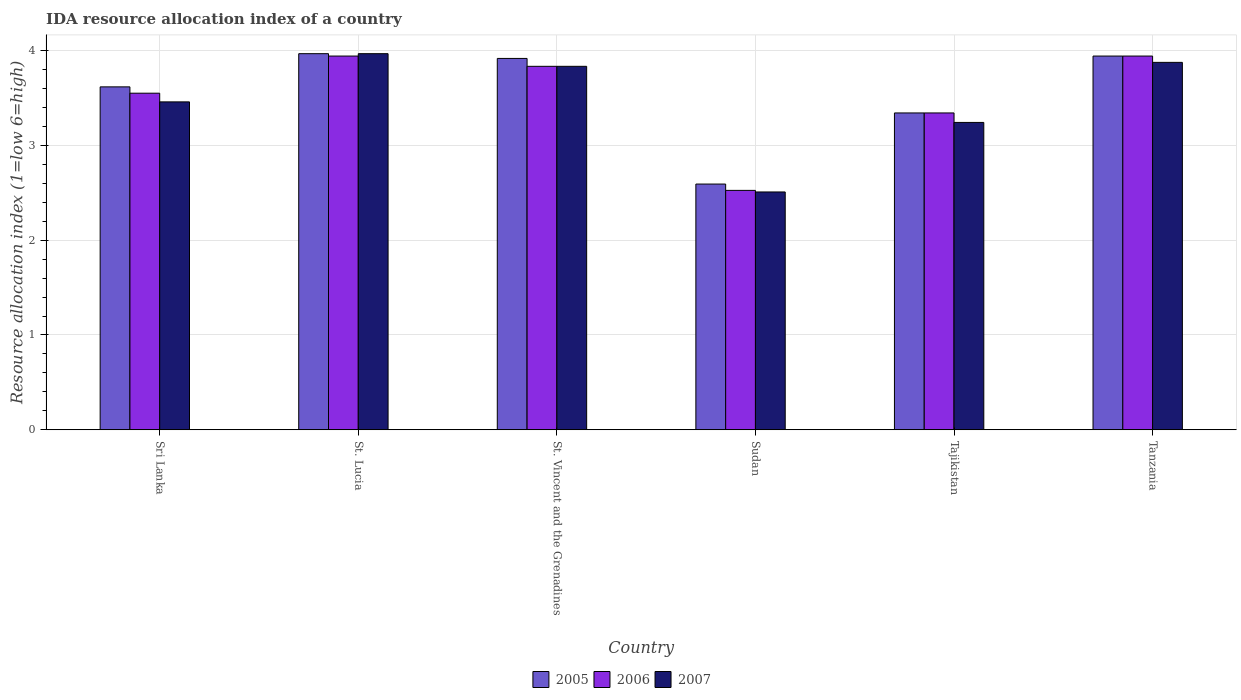How many different coloured bars are there?
Give a very brief answer. 3. How many groups of bars are there?
Your answer should be compact. 6. Are the number of bars on each tick of the X-axis equal?
Provide a succinct answer. Yes. How many bars are there on the 2nd tick from the right?
Provide a succinct answer. 3. What is the label of the 4th group of bars from the left?
Provide a succinct answer. Sudan. What is the IDA resource allocation index in 2006 in St. Vincent and the Grenadines?
Your answer should be compact. 3.83. Across all countries, what is the maximum IDA resource allocation index in 2007?
Give a very brief answer. 3.97. Across all countries, what is the minimum IDA resource allocation index in 2005?
Your answer should be compact. 2.59. In which country was the IDA resource allocation index in 2006 maximum?
Offer a terse response. St. Lucia. In which country was the IDA resource allocation index in 2006 minimum?
Your response must be concise. Sudan. What is the total IDA resource allocation index in 2007 in the graph?
Your answer should be very brief. 20.88. What is the difference between the IDA resource allocation index in 2007 in St. Lucia and that in Tanzania?
Provide a succinct answer. 0.09. What is the difference between the IDA resource allocation index in 2005 in Sri Lanka and the IDA resource allocation index in 2007 in St. Lucia?
Offer a very short reply. -0.35. What is the average IDA resource allocation index in 2005 per country?
Offer a terse response. 3.56. What is the difference between the IDA resource allocation index of/in 2007 and IDA resource allocation index of/in 2006 in St. Lucia?
Offer a very short reply. 0.02. What is the ratio of the IDA resource allocation index in 2007 in St. Lucia to that in Sudan?
Make the answer very short. 1.58. What is the difference between the highest and the second highest IDA resource allocation index in 2005?
Ensure brevity in your answer.  -0.02. What is the difference between the highest and the lowest IDA resource allocation index in 2007?
Your answer should be compact. 1.46. In how many countries, is the IDA resource allocation index in 2005 greater than the average IDA resource allocation index in 2005 taken over all countries?
Offer a terse response. 4. What does the 1st bar from the left in Tanzania represents?
Offer a very short reply. 2005. What does the 1st bar from the right in Tajikistan represents?
Offer a very short reply. 2007. Is it the case that in every country, the sum of the IDA resource allocation index in 2005 and IDA resource allocation index in 2006 is greater than the IDA resource allocation index in 2007?
Ensure brevity in your answer.  Yes. How many bars are there?
Offer a terse response. 18. How many countries are there in the graph?
Provide a succinct answer. 6. What is the difference between two consecutive major ticks on the Y-axis?
Your answer should be compact. 1. Are the values on the major ticks of Y-axis written in scientific E-notation?
Offer a very short reply. No. Does the graph contain any zero values?
Ensure brevity in your answer.  No. Does the graph contain grids?
Ensure brevity in your answer.  Yes. Where does the legend appear in the graph?
Ensure brevity in your answer.  Bottom center. What is the title of the graph?
Make the answer very short. IDA resource allocation index of a country. Does "1977" appear as one of the legend labels in the graph?
Your answer should be compact. No. What is the label or title of the Y-axis?
Keep it short and to the point. Resource allocation index (1=low 6=high). What is the Resource allocation index (1=low 6=high) of 2005 in Sri Lanka?
Your answer should be compact. 3.62. What is the Resource allocation index (1=low 6=high) in 2006 in Sri Lanka?
Provide a short and direct response. 3.55. What is the Resource allocation index (1=low 6=high) in 2007 in Sri Lanka?
Offer a terse response. 3.46. What is the Resource allocation index (1=low 6=high) in 2005 in St. Lucia?
Keep it short and to the point. 3.97. What is the Resource allocation index (1=low 6=high) in 2006 in St. Lucia?
Your answer should be very brief. 3.94. What is the Resource allocation index (1=low 6=high) of 2007 in St. Lucia?
Provide a short and direct response. 3.97. What is the Resource allocation index (1=low 6=high) in 2005 in St. Vincent and the Grenadines?
Keep it short and to the point. 3.92. What is the Resource allocation index (1=low 6=high) of 2006 in St. Vincent and the Grenadines?
Keep it short and to the point. 3.83. What is the Resource allocation index (1=low 6=high) in 2007 in St. Vincent and the Grenadines?
Offer a very short reply. 3.83. What is the Resource allocation index (1=low 6=high) in 2005 in Sudan?
Your answer should be compact. 2.59. What is the Resource allocation index (1=low 6=high) of 2006 in Sudan?
Provide a succinct answer. 2.52. What is the Resource allocation index (1=low 6=high) in 2007 in Sudan?
Ensure brevity in your answer.  2.51. What is the Resource allocation index (1=low 6=high) in 2005 in Tajikistan?
Make the answer very short. 3.34. What is the Resource allocation index (1=low 6=high) in 2006 in Tajikistan?
Your answer should be very brief. 3.34. What is the Resource allocation index (1=low 6=high) of 2007 in Tajikistan?
Provide a succinct answer. 3.24. What is the Resource allocation index (1=low 6=high) of 2005 in Tanzania?
Offer a very short reply. 3.94. What is the Resource allocation index (1=low 6=high) of 2006 in Tanzania?
Give a very brief answer. 3.94. What is the Resource allocation index (1=low 6=high) of 2007 in Tanzania?
Your response must be concise. 3.88. Across all countries, what is the maximum Resource allocation index (1=low 6=high) of 2005?
Provide a succinct answer. 3.97. Across all countries, what is the maximum Resource allocation index (1=low 6=high) of 2006?
Keep it short and to the point. 3.94. Across all countries, what is the maximum Resource allocation index (1=low 6=high) of 2007?
Give a very brief answer. 3.97. Across all countries, what is the minimum Resource allocation index (1=low 6=high) of 2005?
Your response must be concise. 2.59. Across all countries, what is the minimum Resource allocation index (1=low 6=high) of 2006?
Your response must be concise. 2.52. Across all countries, what is the minimum Resource allocation index (1=low 6=high) of 2007?
Your answer should be compact. 2.51. What is the total Resource allocation index (1=low 6=high) in 2005 in the graph?
Offer a terse response. 21.38. What is the total Resource allocation index (1=low 6=high) in 2006 in the graph?
Make the answer very short. 21.13. What is the total Resource allocation index (1=low 6=high) of 2007 in the graph?
Give a very brief answer. 20.88. What is the difference between the Resource allocation index (1=low 6=high) of 2005 in Sri Lanka and that in St. Lucia?
Your response must be concise. -0.35. What is the difference between the Resource allocation index (1=low 6=high) in 2006 in Sri Lanka and that in St. Lucia?
Offer a terse response. -0.39. What is the difference between the Resource allocation index (1=low 6=high) of 2007 in Sri Lanka and that in St. Lucia?
Provide a succinct answer. -0.51. What is the difference between the Resource allocation index (1=low 6=high) of 2006 in Sri Lanka and that in St. Vincent and the Grenadines?
Offer a terse response. -0.28. What is the difference between the Resource allocation index (1=low 6=high) of 2007 in Sri Lanka and that in St. Vincent and the Grenadines?
Your response must be concise. -0.38. What is the difference between the Resource allocation index (1=low 6=high) in 2005 in Sri Lanka and that in Sudan?
Your response must be concise. 1.02. What is the difference between the Resource allocation index (1=low 6=high) in 2006 in Sri Lanka and that in Sudan?
Your answer should be very brief. 1.02. What is the difference between the Resource allocation index (1=low 6=high) in 2007 in Sri Lanka and that in Sudan?
Your answer should be very brief. 0.95. What is the difference between the Resource allocation index (1=low 6=high) of 2005 in Sri Lanka and that in Tajikistan?
Provide a short and direct response. 0.28. What is the difference between the Resource allocation index (1=low 6=high) of 2006 in Sri Lanka and that in Tajikistan?
Make the answer very short. 0.21. What is the difference between the Resource allocation index (1=low 6=high) in 2007 in Sri Lanka and that in Tajikistan?
Give a very brief answer. 0.22. What is the difference between the Resource allocation index (1=low 6=high) of 2005 in Sri Lanka and that in Tanzania?
Your response must be concise. -0.33. What is the difference between the Resource allocation index (1=low 6=high) of 2006 in Sri Lanka and that in Tanzania?
Provide a succinct answer. -0.39. What is the difference between the Resource allocation index (1=low 6=high) of 2007 in Sri Lanka and that in Tanzania?
Provide a succinct answer. -0.42. What is the difference between the Resource allocation index (1=low 6=high) in 2005 in St. Lucia and that in St. Vincent and the Grenadines?
Offer a very short reply. 0.05. What is the difference between the Resource allocation index (1=low 6=high) of 2006 in St. Lucia and that in St. Vincent and the Grenadines?
Make the answer very short. 0.11. What is the difference between the Resource allocation index (1=low 6=high) of 2007 in St. Lucia and that in St. Vincent and the Grenadines?
Keep it short and to the point. 0.13. What is the difference between the Resource allocation index (1=low 6=high) of 2005 in St. Lucia and that in Sudan?
Provide a succinct answer. 1.38. What is the difference between the Resource allocation index (1=low 6=high) in 2006 in St. Lucia and that in Sudan?
Make the answer very short. 1.42. What is the difference between the Resource allocation index (1=low 6=high) in 2007 in St. Lucia and that in Sudan?
Provide a succinct answer. 1.46. What is the difference between the Resource allocation index (1=low 6=high) of 2007 in St. Lucia and that in Tajikistan?
Keep it short and to the point. 0.72. What is the difference between the Resource allocation index (1=low 6=high) in 2005 in St. Lucia and that in Tanzania?
Offer a terse response. 0.03. What is the difference between the Resource allocation index (1=low 6=high) of 2006 in St. Lucia and that in Tanzania?
Your answer should be very brief. 0. What is the difference between the Resource allocation index (1=low 6=high) in 2007 in St. Lucia and that in Tanzania?
Your answer should be very brief. 0.09. What is the difference between the Resource allocation index (1=low 6=high) in 2005 in St. Vincent and the Grenadines and that in Sudan?
Keep it short and to the point. 1.32. What is the difference between the Resource allocation index (1=low 6=high) of 2006 in St. Vincent and the Grenadines and that in Sudan?
Your answer should be compact. 1.31. What is the difference between the Resource allocation index (1=low 6=high) in 2007 in St. Vincent and the Grenadines and that in Sudan?
Your answer should be very brief. 1.32. What is the difference between the Resource allocation index (1=low 6=high) in 2005 in St. Vincent and the Grenadines and that in Tajikistan?
Provide a short and direct response. 0.57. What is the difference between the Resource allocation index (1=low 6=high) in 2006 in St. Vincent and the Grenadines and that in Tajikistan?
Provide a succinct answer. 0.49. What is the difference between the Resource allocation index (1=low 6=high) in 2007 in St. Vincent and the Grenadines and that in Tajikistan?
Provide a succinct answer. 0.59. What is the difference between the Resource allocation index (1=low 6=high) in 2005 in St. Vincent and the Grenadines and that in Tanzania?
Your answer should be compact. -0.03. What is the difference between the Resource allocation index (1=low 6=high) in 2006 in St. Vincent and the Grenadines and that in Tanzania?
Your answer should be very brief. -0.11. What is the difference between the Resource allocation index (1=low 6=high) in 2007 in St. Vincent and the Grenadines and that in Tanzania?
Offer a very short reply. -0.04. What is the difference between the Resource allocation index (1=low 6=high) in 2005 in Sudan and that in Tajikistan?
Give a very brief answer. -0.75. What is the difference between the Resource allocation index (1=low 6=high) of 2006 in Sudan and that in Tajikistan?
Keep it short and to the point. -0.82. What is the difference between the Resource allocation index (1=low 6=high) in 2007 in Sudan and that in Tajikistan?
Give a very brief answer. -0.73. What is the difference between the Resource allocation index (1=low 6=high) of 2005 in Sudan and that in Tanzania?
Keep it short and to the point. -1.35. What is the difference between the Resource allocation index (1=low 6=high) of 2006 in Sudan and that in Tanzania?
Keep it short and to the point. -1.42. What is the difference between the Resource allocation index (1=low 6=high) in 2007 in Sudan and that in Tanzania?
Offer a terse response. -1.37. What is the difference between the Resource allocation index (1=low 6=high) in 2005 in Tajikistan and that in Tanzania?
Your answer should be compact. -0.6. What is the difference between the Resource allocation index (1=low 6=high) of 2007 in Tajikistan and that in Tanzania?
Your answer should be very brief. -0.63. What is the difference between the Resource allocation index (1=low 6=high) of 2005 in Sri Lanka and the Resource allocation index (1=low 6=high) of 2006 in St. Lucia?
Provide a succinct answer. -0.33. What is the difference between the Resource allocation index (1=low 6=high) in 2005 in Sri Lanka and the Resource allocation index (1=low 6=high) in 2007 in St. Lucia?
Give a very brief answer. -0.35. What is the difference between the Resource allocation index (1=low 6=high) in 2006 in Sri Lanka and the Resource allocation index (1=low 6=high) in 2007 in St. Lucia?
Ensure brevity in your answer.  -0.42. What is the difference between the Resource allocation index (1=low 6=high) of 2005 in Sri Lanka and the Resource allocation index (1=low 6=high) of 2006 in St. Vincent and the Grenadines?
Ensure brevity in your answer.  -0.22. What is the difference between the Resource allocation index (1=low 6=high) of 2005 in Sri Lanka and the Resource allocation index (1=low 6=high) of 2007 in St. Vincent and the Grenadines?
Provide a short and direct response. -0.22. What is the difference between the Resource allocation index (1=low 6=high) of 2006 in Sri Lanka and the Resource allocation index (1=low 6=high) of 2007 in St. Vincent and the Grenadines?
Offer a terse response. -0.28. What is the difference between the Resource allocation index (1=low 6=high) in 2005 in Sri Lanka and the Resource allocation index (1=low 6=high) in 2006 in Sudan?
Your response must be concise. 1.09. What is the difference between the Resource allocation index (1=low 6=high) of 2005 in Sri Lanka and the Resource allocation index (1=low 6=high) of 2007 in Sudan?
Your answer should be compact. 1.11. What is the difference between the Resource allocation index (1=low 6=high) of 2006 in Sri Lanka and the Resource allocation index (1=low 6=high) of 2007 in Sudan?
Your answer should be very brief. 1.04. What is the difference between the Resource allocation index (1=low 6=high) in 2005 in Sri Lanka and the Resource allocation index (1=low 6=high) in 2006 in Tajikistan?
Provide a succinct answer. 0.28. What is the difference between the Resource allocation index (1=low 6=high) in 2006 in Sri Lanka and the Resource allocation index (1=low 6=high) in 2007 in Tajikistan?
Provide a short and direct response. 0.31. What is the difference between the Resource allocation index (1=low 6=high) in 2005 in Sri Lanka and the Resource allocation index (1=low 6=high) in 2006 in Tanzania?
Provide a succinct answer. -0.33. What is the difference between the Resource allocation index (1=low 6=high) in 2005 in Sri Lanka and the Resource allocation index (1=low 6=high) in 2007 in Tanzania?
Provide a short and direct response. -0.26. What is the difference between the Resource allocation index (1=low 6=high) of 2006 in Sri Lanka and the Resource allocation index (1=low 6=high) of 2007 in Tanzania?
Keep it short and to the point. -0.33. What is the difference between the Resource allocation index (1=low 6=high) of 2005 in St. Lucia and the Resource allocation index (1=low 6=high) of 2006 in St. Vincent and the Grenadines?
Keep it short and to the point. 0.13. What is the difference between the Resource allocation index (1=low 6=high) of 2005 in St. Lucia and the Resource allocation index (1=low 6=high) of 2007 in St. Vincent and the Grenadines?
Your response must be concise. 0.13. What is the difference between the Resource allocation index (1=low 6=high) of 2006 in St. Lucia and the Resource allocation index (1=low 6=high) of 2007 in St. Vincent and the Grenadines?
Give a very brief answer. 0.11. What is the difference between the Resource allocation index (1=low 6=high) in 2005 in St. Lucia and the Resource allocation index (1=low 6=high) in 2006 in Sudan?
Ensure brevity in your answer.  1.44. What is the difference between the Resource allocation index (1=low 6=high) of 2005 in St. Lucia and the Resource allocation index (1=low 6=high) of 2007 in Sudan?
Your answer should be compact. 1.46. What is the difference between the Resource allocation index (1=low 6=high) in 2006 in St. Lucia and the Resource allocation index (1=low 6=high) in 2007 in Sudan?
Your response must be concise. 1.43. What is the difference between the Resource allocation index (1=low 6=high) of 2005 in St. Lucia and the Resource allocation index (1=low 6=high) of 2007 in Tajikistan?
Keep it short and to the point. 0.72. What is the difference between the Resource allocation index (1=low 6=high) of 2006 in St. Lucia and the Resource allocation index (1=low 6=high) of 2007 in Tajikistan?
Keep it short and to the point. 0.7. What is the difference between the Resource allocation index (1=low 6=high) in 2005 in St. Lucia and the Resource allocation index (1=low 6=high) in 2006 in Tanzania?
Provide a succinct answer. 0.03. What is the difference between the Resource allocation index (1=low 6=high) in 2005 in St. Lucia and the Resource allocation index (1=low 6=high) in 2007 in Tanzania?
Your answer should be compact. 0.09. What is the difference between the Resource allocation index (1=low 6=high) of 2006 in St. Lucia and the Resource allocation index (1=low 6=high) of 2007 in Tanzania?
Give a very brief answer. 0.07. What is the difference between the Resource allocation index (1=low 6=high) in 2005 in St. Vincent and the Grenadines and the Resource allocation index (1=low 6=high) in 2006 in Sudan?
Make the answer very short. 1.39. What is the difference between the Resource allocation index (1=low 6=high) in 2005 in St. Vincent and the Grenadines and the Resource allocation index (1=low 6=high) in 2007 in Sudan?
Provide a succinct answer. 1.41. What is the difference between the Resource allocation index (1=low 6=high) of 2006 in St. Vincent and the Grenadines and the Resource allocation index (1=low 6=high) of 2007 in Sudan?
Offer a terse response. 1.32. What is the difference between the Resource allocation index (1=low 6=high) of 2005 in St. Vincent and the Grenadines and the Resource allocation index (1=low 6=high) of 2006 in Tajikistan?
Your answer should be very brief. 0.57. What is the difference between the Resource allocation index (1=low 6=high) in 2005 in St. Vincent and the Grenadines and the Resource allocation index (1=low 6=high) in 2007 in Tajikistan?
Ensure brevity in your answer.  0.68. What is the difference between the Resource allocation index (1=low 6=high) in 2006 in St. Vincent and the Grenadines and the Resource allocation index (1=low 6=high) in 2007 in Tajikistan?
Your response must be concise. 0.59. What is the difference between the Resource allocation index (1=low 6=high) in 2005 in St. Vincent and the Grenadines and the Resource allocation index (1=low 6=high) in 2006 in Tanzania?
Offer a terse response. -0.03. What is the difference between the Resource allocation index (1=low 6=high) in 2005 in St. Vincent and the Grenadines and the Resource allocation index (1=low 6=high) in 2007 in Tanzania?
Provide a short and direct response. 0.04. What is the difference between the Resource allocation index (1=low 6=high) of 2006 in St. Vincent and the Grenadines and the Resource allocation index (1=low 6=high) of 2007 in Tanzania?
Make the answer very short. -0.04. What is the difference between the Resource allocation index (1=low 6=high) of 2005 in Sudan and the Resource allocation index (1=low 6=high) of 2006 in Tajikistan?
Give a very brief answer. -0.75. What is the difference between the Resource allocation index (1=low 6=high) in 2005 in Sudan and the Resource allocation index (1=low 6=high) in 2007 in Tajikistan?
Give a very brief answer. -0.65. What is the difference between the Resource allocation index (1=low 6=high) of 2006 in Sudan and the Resource allocation index (1=low 6=high) of 2007 in Tajikistan?
Offer a very short reply. -0.72. What is the difference between the Resource allocation index (1=low 6=high) of 2005 in Sudan and the Resource allocation index (1=low 6=high) of 2006 in Tanzania?
Provide a short and direct response. -1.35. What is the difference between the Resource allocation index (1=low 6=high) in 2005 in Sudan and the Resource allocation index (1=low 6=high) in 2007 in Tanzania?
Provide a short and direct response. -1.28. What is the difference between the Resource allocation index (1=low 6=high) of 2006 in Sudan and the Resource allocation index (1=low 6=high) of 2007 in Tanzania?
Your answer should be very brief. -1.35. What is the difference between the Resource allocation index (1=low 6=high) of 2005 in Tajikistan and the Resource allocation index (1=low 6=high) of 2007 in Tanzania?
Your response must be concise. -0.53. What is the difference between the Resource allocation index (1=low 6=high) in 2006 in Tajikistan and the Resource allocation index (1=low 6=high) in 2007 in Tanzania?
Provide a short and direct response. -0.53. What is the average Resource allocation index (1=low 6=high) of 2005 per country?
Keep it short and to the point. 3.56. What is the average Resource allocation index (1=low 6=high) in 2006 per country?
Your response must be concise. 3.52. What is the average Resource allocation index (1=low 6=high) of 2007 per country?
Provide a succinct answer. 3.48. What is the difference between the Resource allocation index (1=low 6=high) of 2005 and Resource allocation index (1=low 6=high) of 2006 in Sri Lanka?
Ensure brevity in your answer.  0.07. What is the difference between the Resource allocation index (1=low 6=high) of 2005 and Resource allocation index (1=low 6=high) of 2007 in Sri Lanka?
Your answer should be very brief. 0.16. What is the difference between the Resource allocation index (1=low 6=high) of 2006 and Resource allocation index (1=low 6=high) of 2007 in Sri Lanka?
Offer a terse response. 0.09. What is the difference between the Resource allocation index (1=low 6=high) of 2005 and Resource allocation index (1=low 6=high) of 2006 in St. Lucia?
Offer a very short reply. 0.03. What is the difference between the Resource allocation index (1=low 6=high) in 2006 and Resource allocation index (1=low 6=high) in 2007 in St. Lucia?
Your response must be concise. -0.03. What is the difference between the Resource allocation index (1=low 6=high) in 2005 and Resource allocation index (1=low 6=high) in 2006 in St. Vincent and the Grenadines?
Give a very brief answer. 0.08. What is the difference between the Resource allocation index (1=low 6=high) of 2005 and Resource allocation index (1=low 6=high) of 2007 in St. Vincent and the Grenadines?
Make the answer very short. 0.08. What is the difference between the Resource allocation index (1=low 6=high) in 2005 and Resource allocation index (1=low 6=high) in 2006 in Sudan?
Give a very brief answer. 0.07. What is the difference between the Resource allocation index (1=low 6=high) in 2005 and Resource allocation index (1=low 6=high) in 2007 in Sudan?
Ensure brevity in your answer.  0.08. What is the difference between the Resource allocation index (1=low 6=high) of 2006 and Resource allocation index (1=low 6=high) of 2007 in Sudan?
Give a very brief answer. 0.02. What is the difference between the Resource allocation index (1=low 6=high) in 2005 and Resource allocation index (1=low 6=high) in 2007 in Tanzania?
Your answer should be compact. 0.07. What is the difference between the Resource allocation index (1=low 6=high) in 2006 and Resource allocation index (1=low 6=high) in 2007 in Tanzania?
Make the answer very short. 0.07. What is the ratio of the Resource allocation index (1=low 6=high) in 2005 in Sri Lanka to that in St. Lucia?
Your answer should be very brief. 0.91. What is the ratio of the Resource allocation index (1=low 6=high) in 2006 in Sri Lanka to that in St. Lucia?
Your answer should be compact. 0.9. What is the ratio of the Resource allocation index (1=low 6=high) of 2007 in Sri Lanka to that in St. Lucia?
Provide a succinct answer. 0.87. What is the ratio of the Resource allocation index (1=low 6=high) in 2005 in Sri Lanka to that in St. Vincent and the Grenadines?
Your answer should be very brief. 0.92. What is the ratio of the Resource allocation index (1=low 6=high) in 2006 in Sri Lanka to that in St. Vincent and the Grenadines?
Ensure brevity in your answer.  0.93. What is the ratio of the Resource allocation index (1=low 6=high) of 2007 in Sri Lanka to that in St. Vincent and the Grenadines?
Offer a very short reply. 0.9. What is the ratio of the Resource allocation index (1=low 6=high) in 2005 in Sri Lanka to that in Sudan?
Offer a very short reply. 1.4. What is the ratio of the Resource allocation index (1=low 6=high) in 2006 in Sri Lanka to that in Sudan?
Your response must be concise. 1.41. What is the ratio of the Resource allocation index (1=low 6=high) of 2007 in Sri Lanka to that in Sudan?
Offer a very short reply. 1.38. What is the ratio of the Resource allocation index (1=low 6=high) of 2005 in Sri Lanka to that in Tajikistan?
Give a very brief answer. 1.08. What is the ratio of the Resource allocation index (1=low 6=high) of 2006 in Sri Lanka to that in Tajikistan?
Your answer should be very brief. 1.06. What is the ratio of the Resource allocation index (1=low 6=high) in 2007 in Sri Lanka to that in Tajikistan?
Keep it short and to the point. 1.07. What is the ratio of the Resource allocation index (1=low 6=high) of 2005 in Sri Lanka to that in Tanzania?
Give a very brief answer. 0.92. What is the ratio of the Resource allocation index (1=low 6=high) of 2006 in Sri Lanka to that in Tanzania?
Ensure brevity in your answer.  0.9. What is the ratio of the Resource allocation index (1=low 6=high) of 2007 in Sri Lanka to that in Tanzania?
Your response must be concise. 0.89. What is the ratio of the Resource allocation index (1=low 6=high) in 2005 in St. Lucia to that in St. Vincent and the Grenadines?
Offer a terse response. 1.01. What is the ratio of the Resource allocation index (1=low 6=high) of 2006 in St. Lucia to that in St. Vincent and the Grenadines?
Offer a very short reply. 1.03. What is the ratio of the Resource allocation index (1=low 6=high) in 2007 in St. Lucia to that in St. Vincent and the Grenadines?
Provide a succinct answer. 1.03. What is the ratio of the Resource allocation index (1=low 6=high) in 2005 in St. Lucia to that in Sudan?
Your answer should be very brief. 1.53. What is the ratio of the Resource allocation index (1=low 6=high) of 2006 in St. Lucia to that in Sudan?
Offer a very short reply. 1.56. What is the ratio of the Resource allocation index (1=low 6=high) of 2007 in St. Lucia to that in Sudan?
Provide a short and direct response. 1.58. What is the ratio of the Resource allocation index (1=low 6=high) of 2005 in St. Lucia to that in Tajikistan?
Your answer should be very brief. 1.19. What is the ratio of the Resource allocation index (1=low 6=high) in 2006 in St. Lucia to that in Tajikistan?
Your response must be concise. 1.18. What is the ratio of the Resource allocation index (1=low 6=high) of 2007 in St. Lucia to that in Tajikistan?
Your answer should be very brief. 1.22. What is the ratio of the Resource allocation index (1=low 6=high) of 2005 in St. Lucia to that in Tanzania?
Your answer should be compact. 1.01. What is the ratio of the Resource allocation index (1=low 6=high) of 2006 in St. Lucia to that in Tanzania?
Keep it short and to the point. 1. What is the ratio of the Resource allocation index (1=low 6=high) in 2007 in St. Lucia to that in Tanzania?
Your answer should be compact. 1.02. What is the ratio of the Resource allocation index (1=low 6=high) of 2005 in St. Vincent and the Grenadines to that in Sudan?
Provide a succinct answer. 1.51. What is the ratio of the Resource allocation index (1=low 6=high) in 2006 in St. Vincent and the Grenadines to that in Sudan?
Your response must be concise. 1.52. What is the ratio of the Resource allocation index (1=low 6=high) of 2007 in St. Vincent and the Grenadines to that in Sudan?
Provide a succinct answer. 1.53. What is the ratio of the Resource allocation index (1=low 6=high) in 2005 in St. Vincent and the Grenadines to that in Tajikistan?
Make the answer very short. 1.17. What is the ratio of the Resource allocation index (1=low 6=high) of 2006 in St. Vincent and the Grenadines to that in Tajikistan?
Give a very brief answer. 1.15. What is the ratio of the Resource allocation index (1=low 6=high) of 2007 in St. Vincent and the Grenadines to that in Tajikistan?
Ensure brevity in your answer.  1.18. What is the ratio of the Resource allocation index (1=low 6=high) in 2005 in St. Vincent and the Grenadines to that in Tanzania?
Your answer should be very brief. 0.99. What is the ratio of the Resource allocation index (1=low 6=high) of 2006 in St. Vincent and the Grenadines to that in Tanzania?
Ensure brevity in your answer.  0.97. What is the ratio of the Resource allocation index (1=low 6=high) of 2007 in St. Vincent and the Grenadines to that in Tanzania?
Your answer should be very brief. 0.99. What is the ratio of the Resource allocation index (1=low 6=high) in 2005 in Sudan to that in Tajikistan?
Provide a short and direct response. 0.78. What is the ratio of the Resource allocation index (1=low 6=high) in 2006 in Sudan to that in Tajikistan?
Offer a very short reply. 0.76. What is the ratio of the Resource allocation index (1=low 6=high) in 2007 in Sudan to that in Tajikistan?
Your response must be concise. 0.77. What is the ratio of the Resource allocation index (1=low 6=high) of 2005 in Sudan to that in Tanzania?
Offer a very short reply. 0.66. What is the ratio of the Resource allocation index (1=low 6=high) in 2006 in Sudan to that in Tanzania?
Offer a very short reply. 0.64. What is the ratio of the Resource allocation index (1=low 6=high) of 2007 in Sudan to that in Tanzania?
Ensure brevity in your answer.  0.65. What is the ratio of the Resource allocation index (1=low 6=high) in 2005 in Tajikistan to that in Tanzania?
Keep it short and to the point. 0.85. What is the ratio of the Resource allocation index (1=low 6=high) in 2006 in Tajikistan to that in Tanzania?
Ensure brevity in your answer.  0.85. What is the ratio of the Resource allocation index (1=low 6=high) of 2007 in Tajikistan to that in Tanzania?
Ensure brevity in your answer.  0.84. What is the difference between the highest and the second highest Resource allocation index (1=low 6=high) of 2005?
Offer a terse response. 0.03. What is the difference between the highest and the second highest Resource allocation index (1=low 6=high) in 2006?
Your answer should be compact. 0. What is the difference between the highest and the second highest Resource allocation index (1=low 6=high) in 2007?
Provide a short and direct response. 0.09. What is the difference between the highest and the lowest Resource allocation index (1=low 6=high) of 2005?
Ensure brevity in your answer.  1.38. What is the difference between the highest and the lowest Resource allocation index (1=low 6=high) of 2006?
Your response must be concise. 1.42. What is the difference between the highest and the lowest Resource allocation index (1=low 6=high) of 2007?
Ensure brevity in your answer.  1.46. 